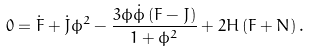<formula> <loc_0><loc_0><loc_500><loc_500>0 = \dot { F } + \dot { J } \phi ^ { 2 } - \frac { 3 \phi \dot { \phi } \left ( F - J \right ) } { 1 + \phi ^ { 2 } } + 2 H \left ( F + N \right ) .</formula> 